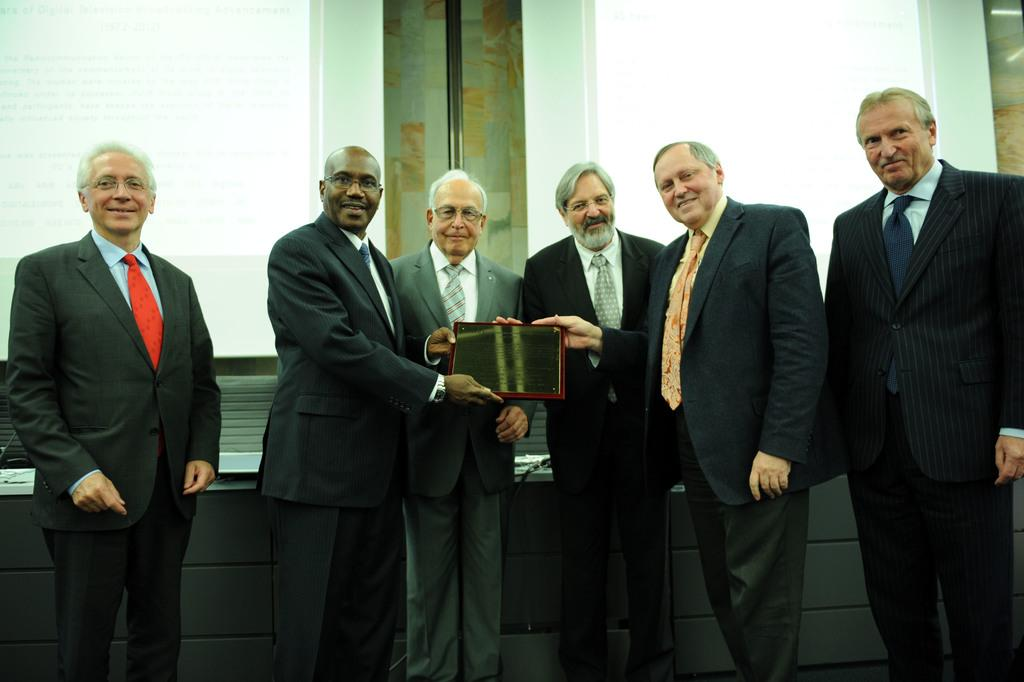How many people are visible in the image? There are many people standing in the image. What are some of the people holding in the image? Some of the people are holding a momentum. What can be seen in the background of the image? There is a wall in the background of the image. What type of breath can be seen coming from the people in the image? There is no visible breath coming from the people in the image. What nerve is responsible for the people's ability to hold the momentum in the image? The image does not provide information about the specific nerves of the people holding the momentum. 